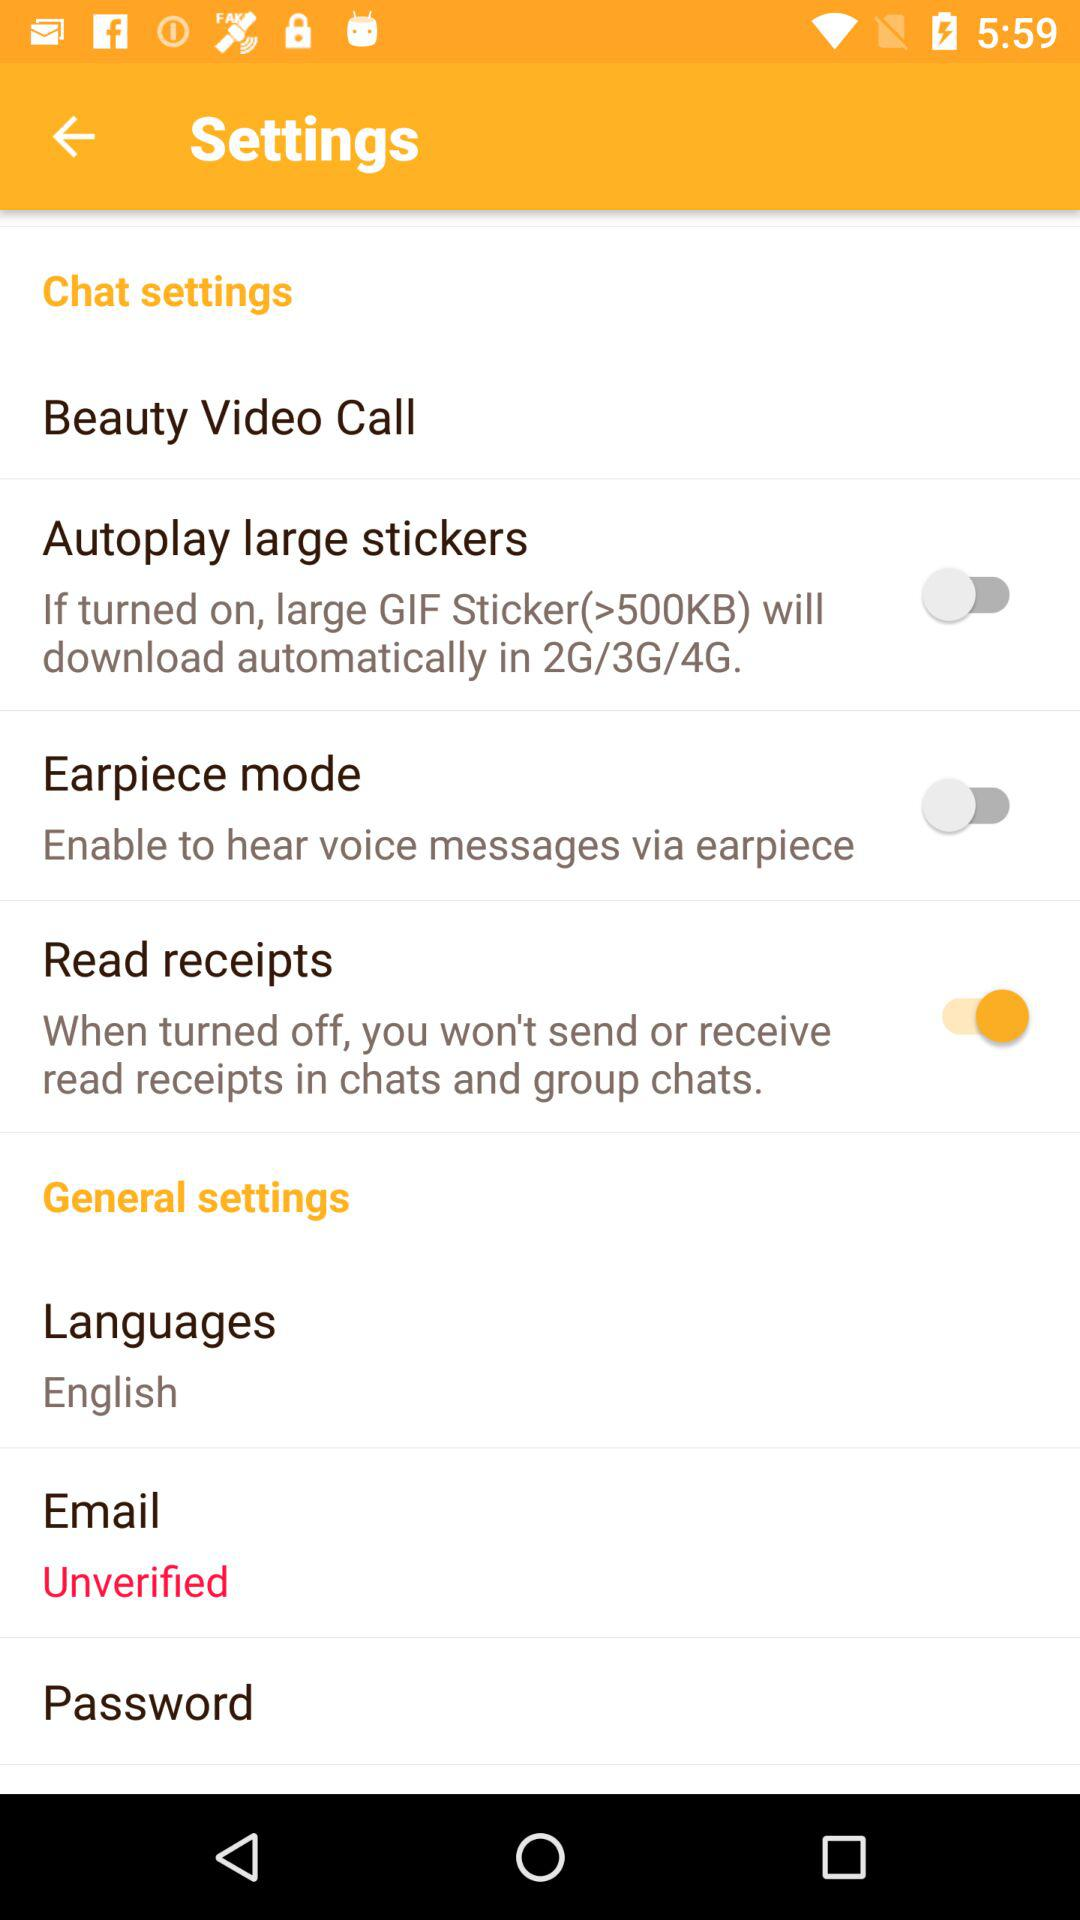Which language is selected? The selected language is English. 